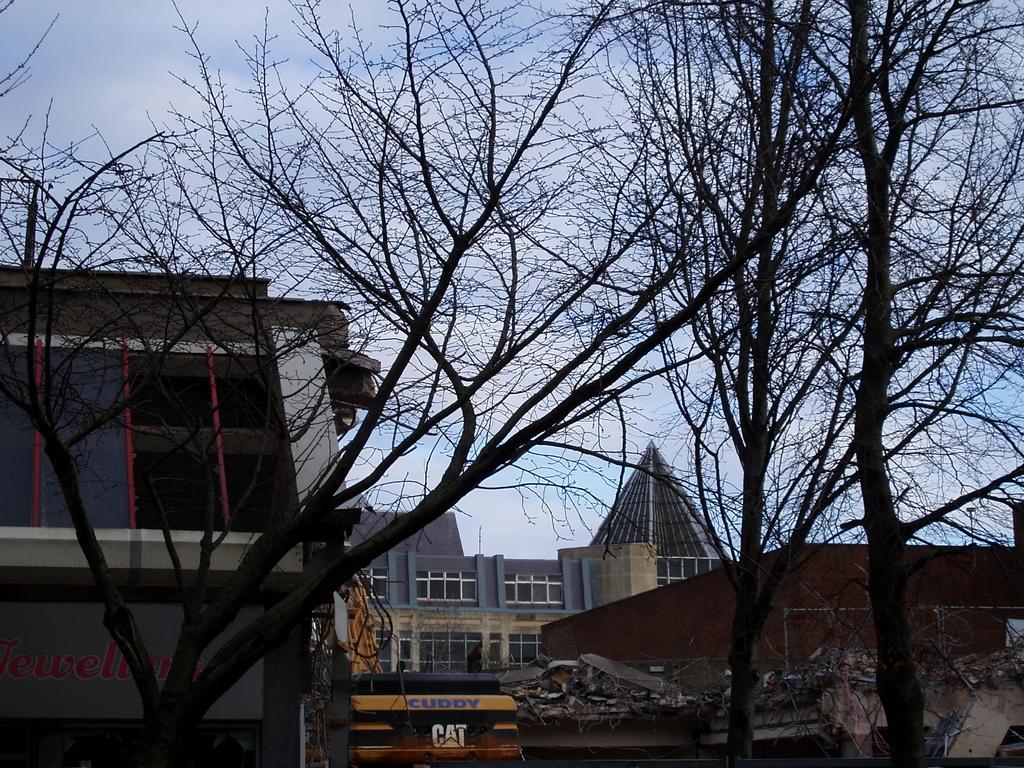What type of natural elements can be seen in the image? There are trees in the image. What type of man-made structures are present in the image? There are buildings in the image. What mode of transportation can be seen in the image? There is a vehicle in the image. What is visible in the background of the image? The sky is visible in the background of the image. Can you tell me what type of glass the writer is using in the image? There is no writer or glass present in the image. What kind of rock is being used as a paperweight in the image? There is no rock or paperweight present in the image. 